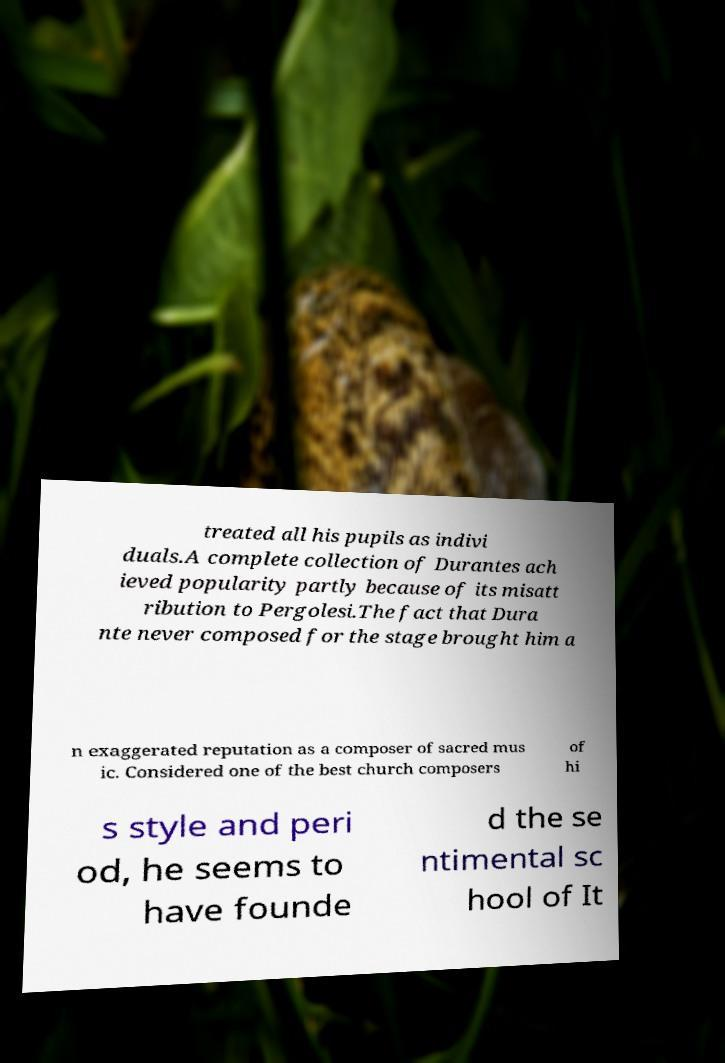Please identify and transcribe the text found in this image. treated all his pupils as indivi duals.A complete collection of Durantes ach ieved popularity partly because of its misatt ribution to Pergolesi.The fact that Dura nte never composed for the stage brought him a n exaggerated reputation as a composer of sacred mus ic. Considered one of the best church composers of hi s style and peri od, he seems to have founde d the se ntimental sc hool of It 